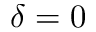<formula> <loc_0><loc_0><loc_500><loc_500>\delta = 0</formula> 